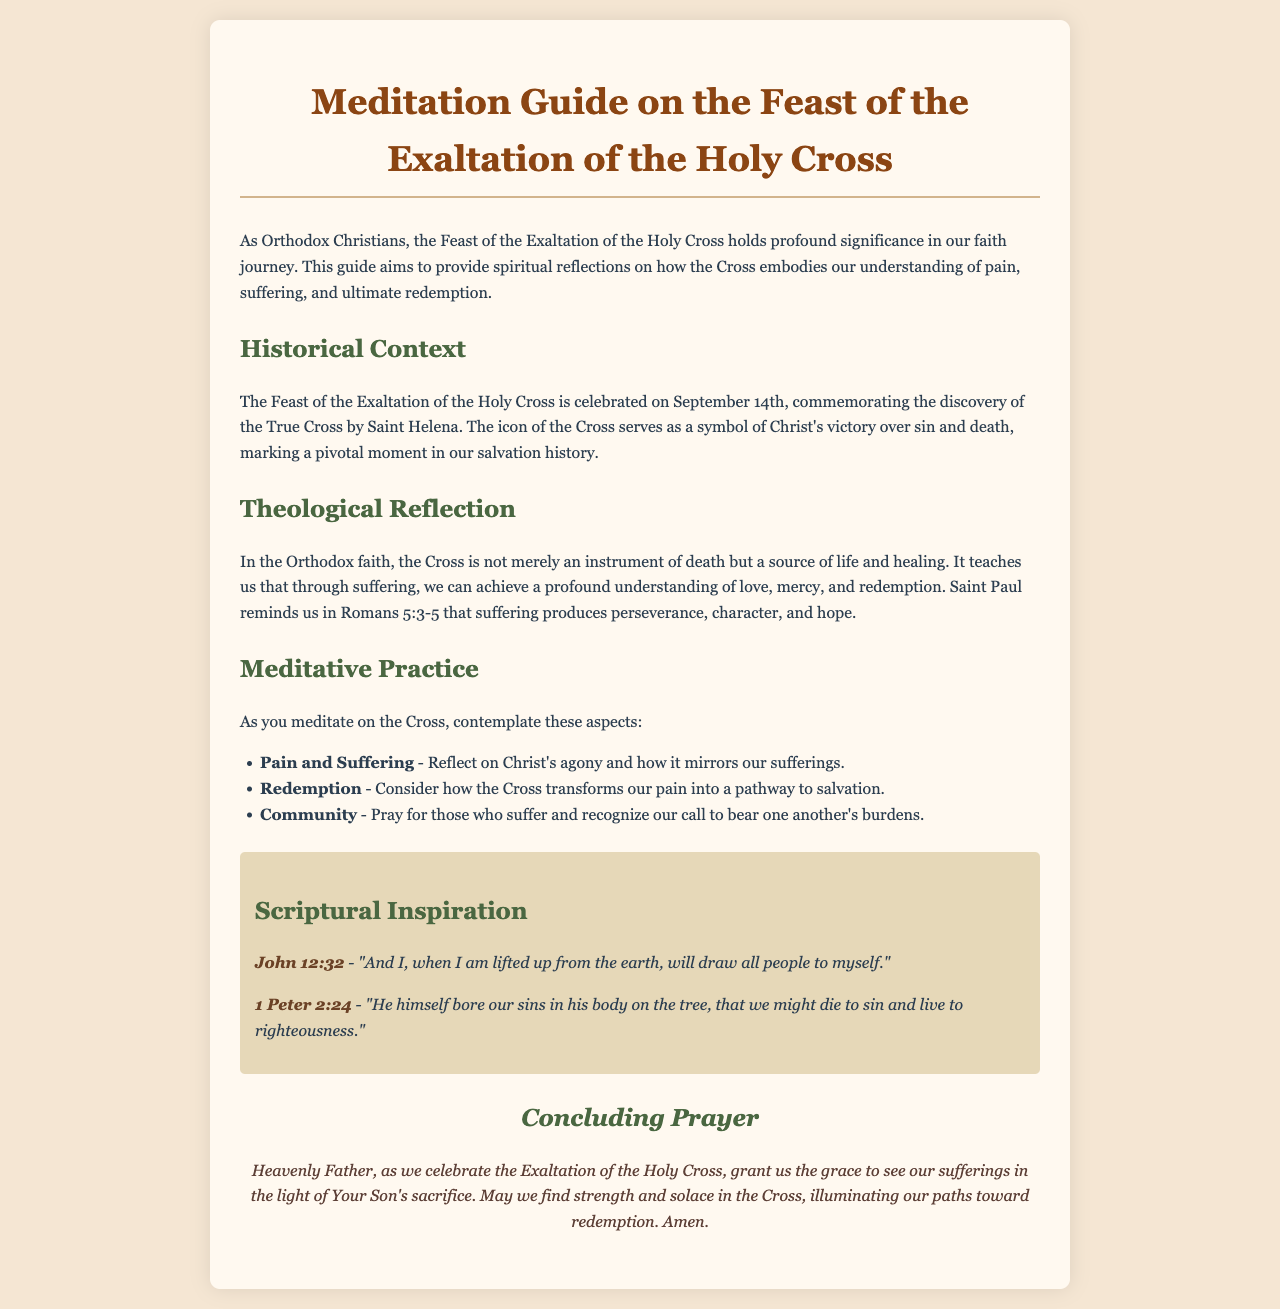What is the title of the document? The title is prominently displayed at the top of the document, indicating the focus on a specific theological subject.
Answer: Meditation Guide on the Feast of the Exaltation of the Holy Cross On what date is the Feast of the Exaltation of the Holy Cross celebrated? The document specifies the date of this significant feast within the Orthodox Christian calendar.
Answer: September 14th Who discovered the True Cross? The historical context recounts the individual responsible for finding the True Cross, linking her to the celebration.
Answer: Saint Helena What scripture is cited in relation to Christ being lifted up? The document includes specific verses that provide biblical support for its reflections on the Cross.
Answer: John 12:32 What does suffering produce according to Romans 5:3-5? The theological reflection section discusses the outcomes of suffering as highlighted by Saint Paul.
Answer: Perseverance, character, and hope What are the three aspects to contemplate during meditation on the Cross? The document lists specific themes for reflection in the meditative practice section, highlighting key theological concepts.
Answer: Pain and Suffering, Redemption, Community What is the concluding prayer's main focus? The concluding prayer encapsulates the overall objective of the meditation guide, emphasizing the relationship between suffering and redemption.
Answer: Strength and solace in the Cross What does the Cross symbolize in the Orthodox faith? The theological reflection addresses the significance of the Cross in relation to life and healing.
Answer: A source of life and healing 